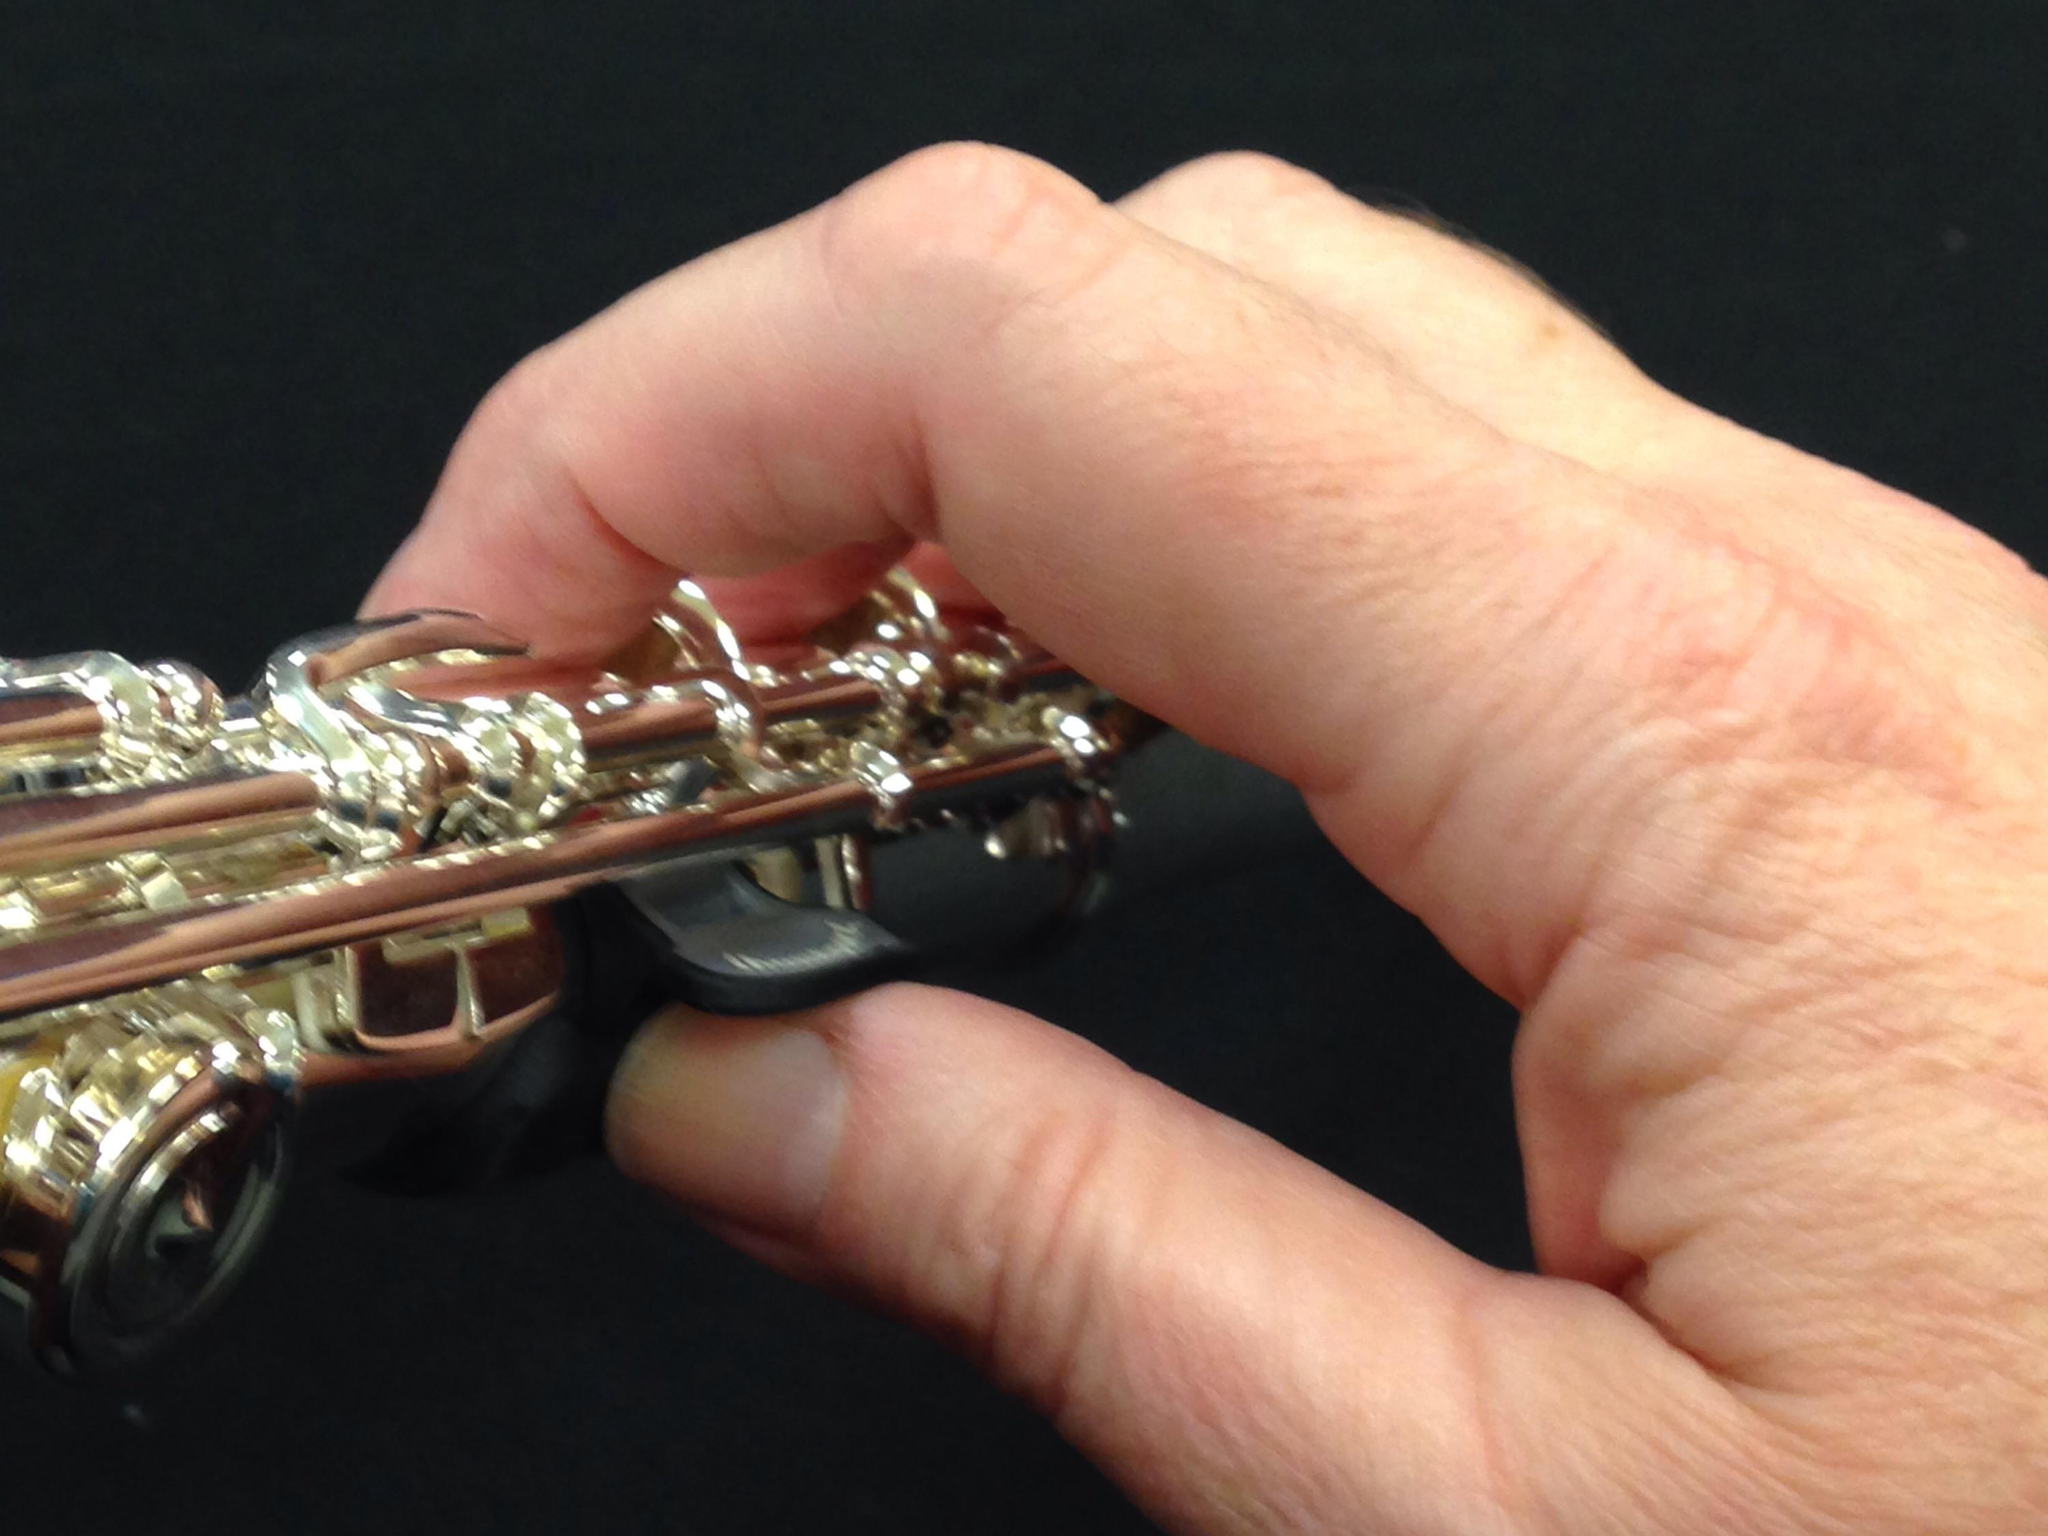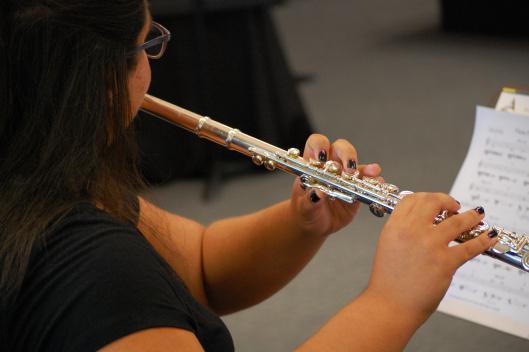The first image is the image on the left, the second image is the image on the right. Assess this claim about the two images: "There are two flute being played and the end is facing left.". Correct or not? Answer yes or no. No. The first image is the image on the left, the second image is the image on the right. For the images shown, is this caption "There are four hands." true? Answer yes or no. No. 